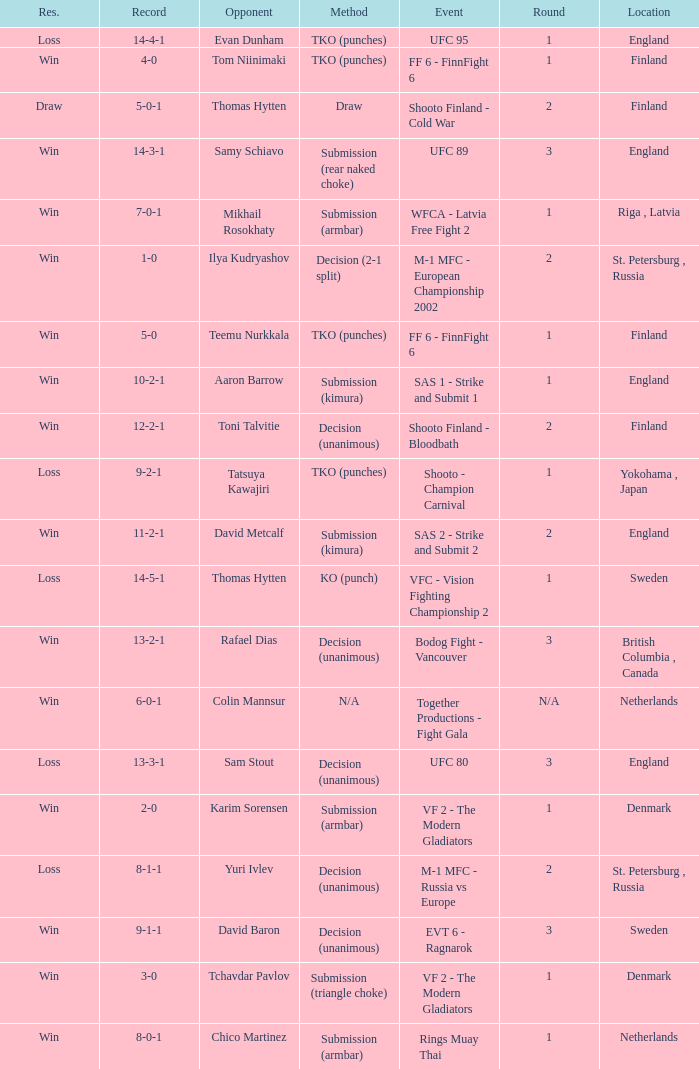What is the round in Finland with a draw for method? 2.0. 